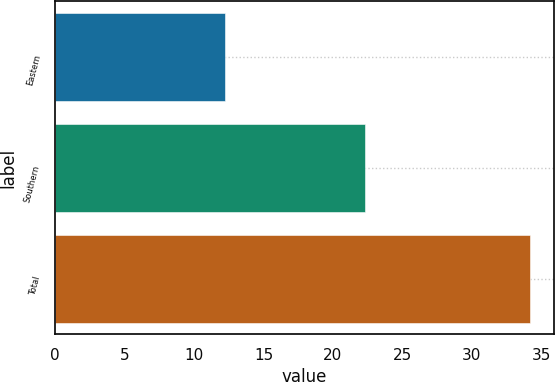Convert chart to OTSL. <chart><loc_0><loc_0><loc_500><loc_500><bar_chart><fcel>Eastern<fcel>Southern<fcel>Total<nl><fcel>12.2<fcel>22.3<fcel>34.2<nl></chart> 